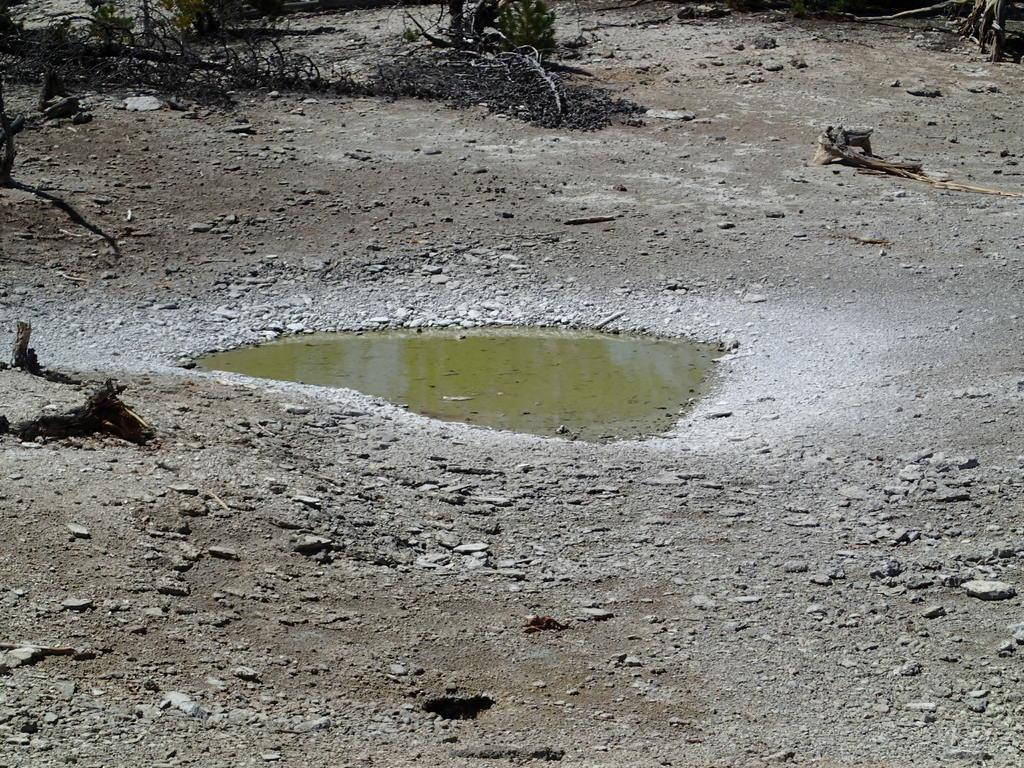What is located in the middle of the ground in the image? There is water in the middle of the ground in the image. What surrounds the water in the image? There are stones around the water. What type of vegetation can be seen in the image? There are dried plants in the image. How does the comb help in the care process of the plants in the image? There is no comb present in the image, and therefore no care process involving a comb can be observed. 